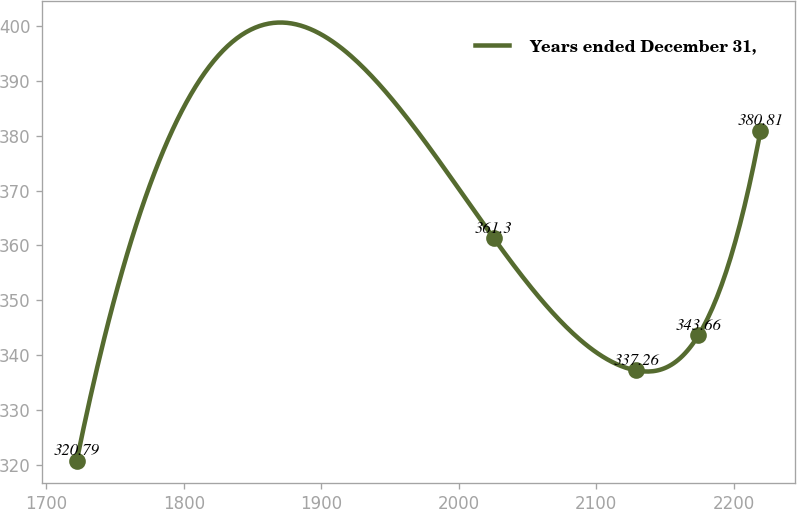Convert chart. <chart><loc_0><loc_0><loc_500><loc_500><line_chart><ecel><fcel>Years ended December 31,<nl><fcel>1722.06<fcel>320.79<nl><fcel>2025.53<fcel>361.3<nl><fcel>2129.2<fcel>337.26<nl><fcel>2174.32<fcel>343.66<nl><fcel>2219.44<fcel>380.81<nl></chart> 